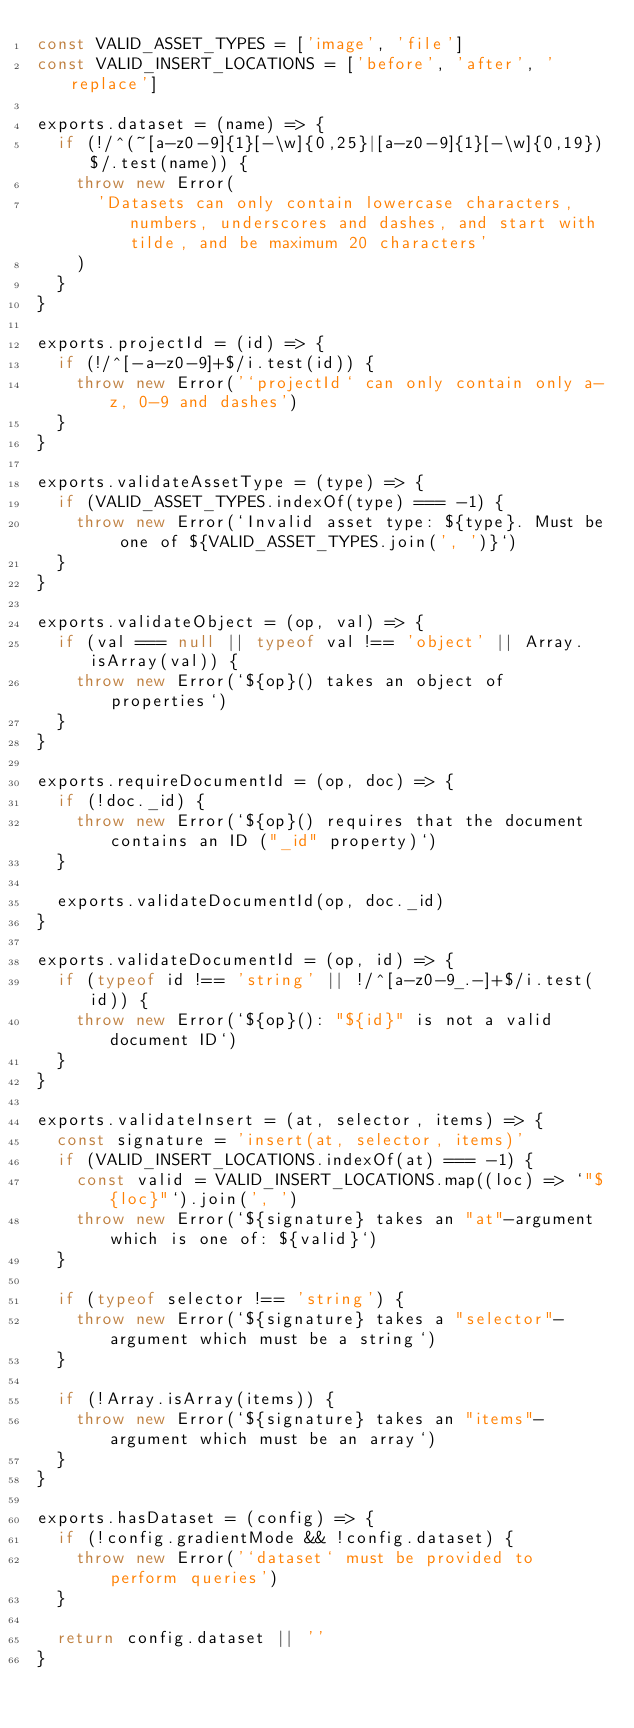Convert code to text. <code><loc_0><loc_0><loc_500><loc_500><_JavaScript_>const VALID_ASSET_TYPES = ['image', 'file']
const VALID_INSERT_LOCATIONS = ['before', 'after', 'replace']

exports.dataset = (name) => {
  if (!/^(~[a-z0-9]{1}[-\w]{0,25}|[a-z0-9]{1}[-\w]{0,19})$/.test(name)) {
    throw new Error(
      'Datasets can only contain lowercase characters, numbers, underscores and dashes, and start with tilde, and be maximum 20 characters'
    )
  }
}

exports.projectId = (id) => {
  if (!/^[-a-z0-9]+$/i.test(id)) {
    throw new Error('`projectId` can only contain only a-z, 0-9 and dashes')
  }
}

exports.validateAssetType = (type) => {
  if (VALID_ASSET_TYPES.indexOf(type) === -1) {
    throw new Error(`Invalid asset type: ${type}. Must be one of ${VALID_ASSET_TYPES.join(', ')}`)
  }
}

exports.validateObject = (op, val) => {
  if (val === null || typeof val !== 'object' || Array.isArray(val)) {
    throw new Error(`${op}() takes an object of properties`)
  }
}

exports.requireDocumentId = (op, doc) => {
  if (!doc._id) {
    throw new Error(`${op}() requires that the document contains an ID ("_id" property)`)
  }

  exports.validateDocumentId(op, doc._id)
}

exports.validateDocumentId = (op, id) => {
  if (typeof id !== 'string' || !/^[a-z0-9_.-]+$/i.test(id)) {
    throw new Error(`${op}(): "${id}" is not a valid document ID`)
  }
}

exports.validateInsert = (at, selector, items) => {
  const signature = 'insert(at, selector, items)'
  if (VALID_INSERT_LOCATIONS.indexOf(at) === -1) {
    const valid = VALID_INSERT_LOCATIONS.map((loc) => `"${loc}"`).join(', ')
    throw new Error(`${signature} takes an "at"-argument which is one of: ${valid}`)
  }

  if (typeof selector !== 'string') {
    throw new Error(`${signature} takes a "selector"-argument which must be a string`)
  }

  if (!Array.isArray(items)) {
    throw new Error(`${signature} takes an "items"-argument which must be an array`)
  }
}

exports.hasDataset = (config) => {
  if (!config.gradientMode && !config.dataset) {
    throw new Error('`dataset` must be provided to perform queries')
  }

  return config.dataset || ''
}
</code> 